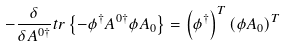<formula> <loc_0><loc_0><loc_500><loc_500>- \frac { \delta } { \delta A ^ { 0 \dagger } } t r \left \{ - \phi ^ { \dagger } A ^ { 0 \dagger } \phi A _ { 0 } \right \} = \left ( \phi ^ { \dagger } \right ) ^ { T } \left ( \phi A _ { 0 } \right ) ^ { T }</formula> 